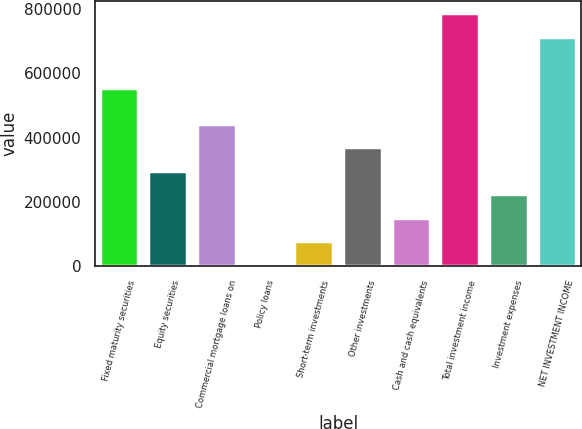Convert chart to OTSL. <chart><loc_0><loc_0><loc_500><loc_500><bar_chart><fcel>Fixed maturity securities<fcel>Equity securities<fcel>Commercial mortgage loans on<fcel>Policy loans<fcel>Short-term investments<fcel>Other investments<fcel>Cash and cash equivalents<fcel>Total investment income<fcel>Investment expenses<fcel>NET INVESTMENT INCOME<nl><fcel>553668<fcel>296140<fcel>442608<fcel>3204<fcel>76438<fcel>369374<fcel>149672<fcel>786362<fcel>222906<fcel>713128<nl></chart> 